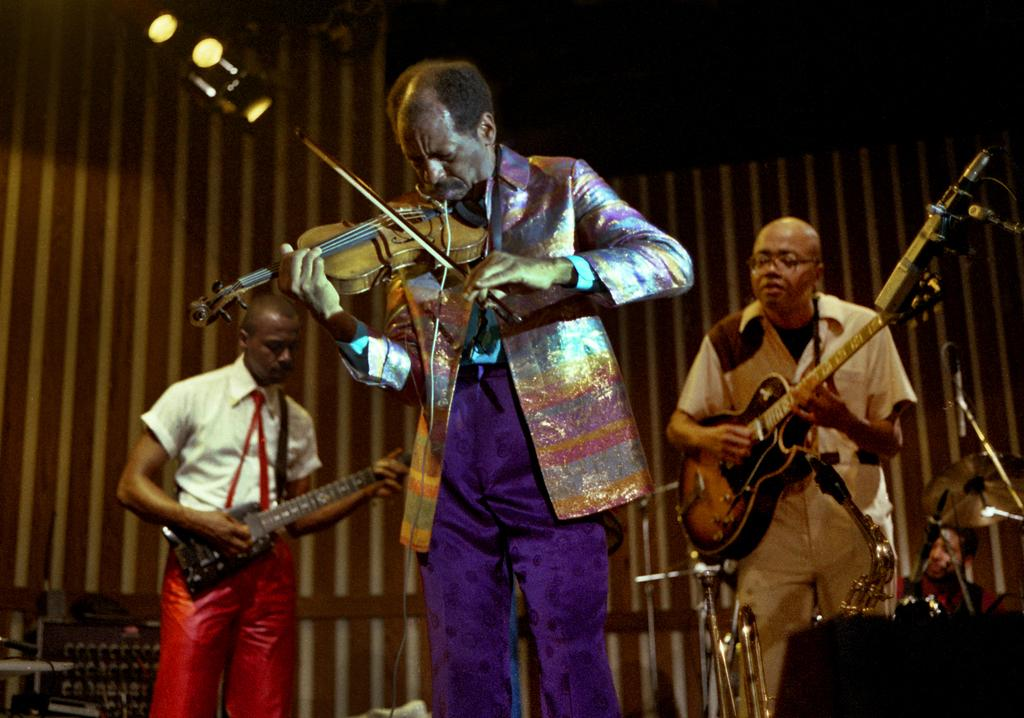How many people are in the image? There are three people in the image. Where are the people located in the image? The people are standing on a stage. What are the people holding in the image? The people are holding musical instruments. What are the people doing with the musical instruments? The people are playing the musical instruments. What type of boat can be seen in the image? There is no boat present in the image. What force is causing the people to play their instruments? There is no indication of a force causing the people to play their instruments in the image. 